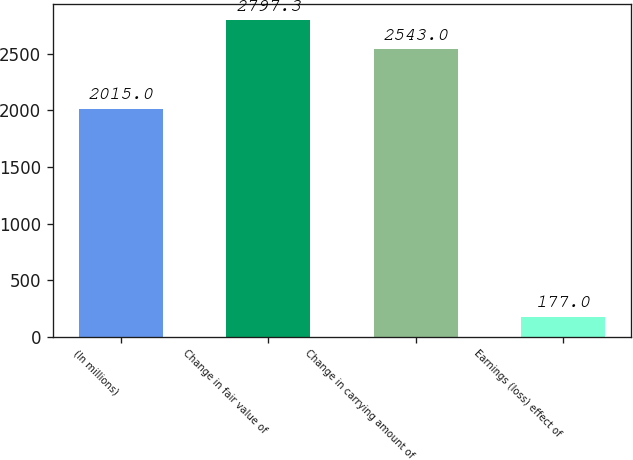<chart> <loc_0><loc_0><loc_500><loc_500><bar_chart><fcel>(In millions)<fcel>Change in fair value of<fcel>Change in carrying amount of<fcel>Earnings (loss) effect of<nl><fcel>2015<fcel>2797.3<fcel>2543<fcel>177<nl></chart> 